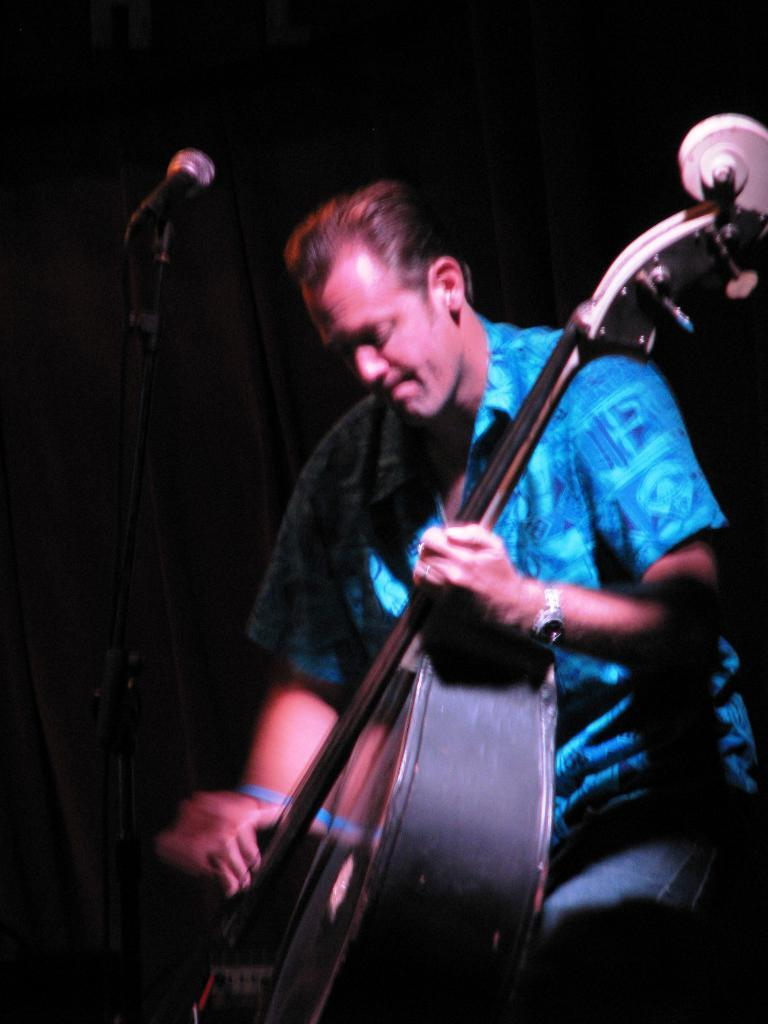What is the main subject of the image? There is a person in the image. What is the person doing in the image? The person is playing a musical instrument. What object is in front of the person? There is a microphone in front of the person. What type of rod can be seen supporting the credit in the image? There is no rod or credit present in the image; it only features a person playing a musical instrument and a microphone. 